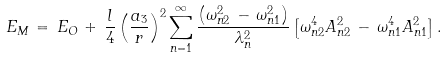<formula> <loc_0><loc_0><loc_500><loc_500>E _ { M } \, = \, E _ { O } \, + \, \frac { l } { 4 } \left ( \frac { a _ { 3 } } { r } \right ) ^ { 2 } \sum _ { n = 1 } ^ { \infty } \frac { \left ( \omega _ { n 2 } ^ { 2 } \, - \, \omega _ { n 1 } ^ { 2 } \right ) } { \lambda _ { n } ^ { 2 } } \left [ \omega _ { n 2 } ^ { 4 } A _ { n 2 } ^ { 2 } \, - \, \omega _ { n 1 } ^ { 4 } A _ { n 1 } ^ { 2 } \right ] .</formula> 